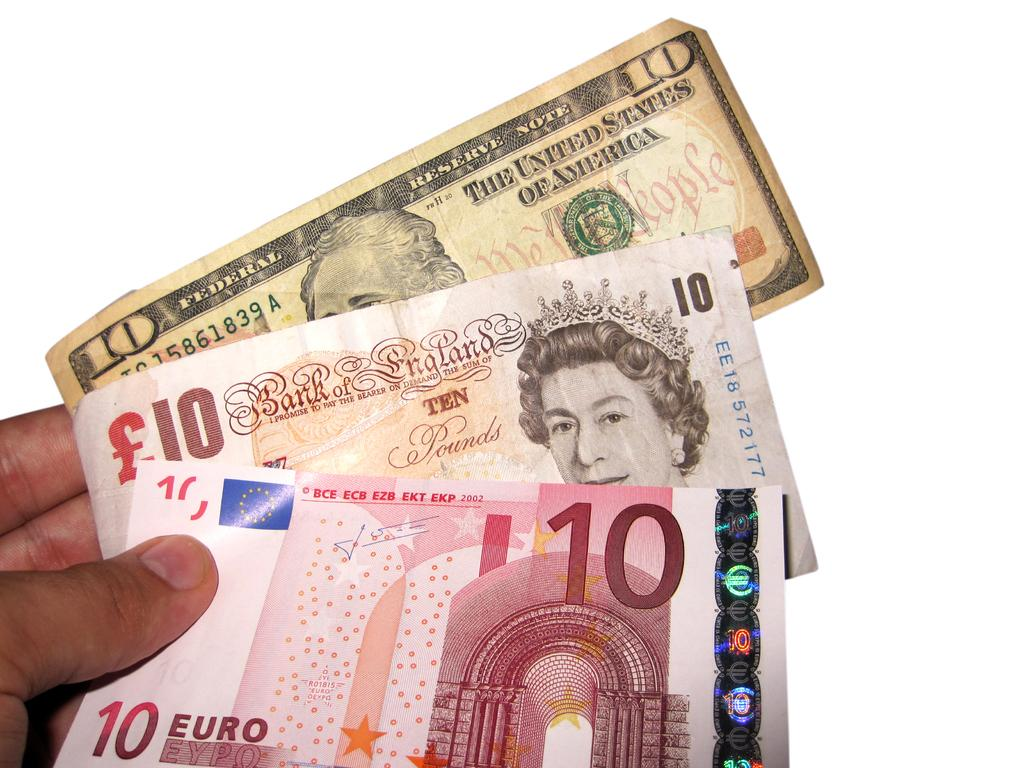What is the person holding in the image? The person is holding ten rupee notes in the image. Can you describe the ten rupee notes? The ten rupee notes are from three different states. How many apples are on the hill in the image? There are no apples or hills present in the image; it features a person holding ten rupee notes from three different states. 